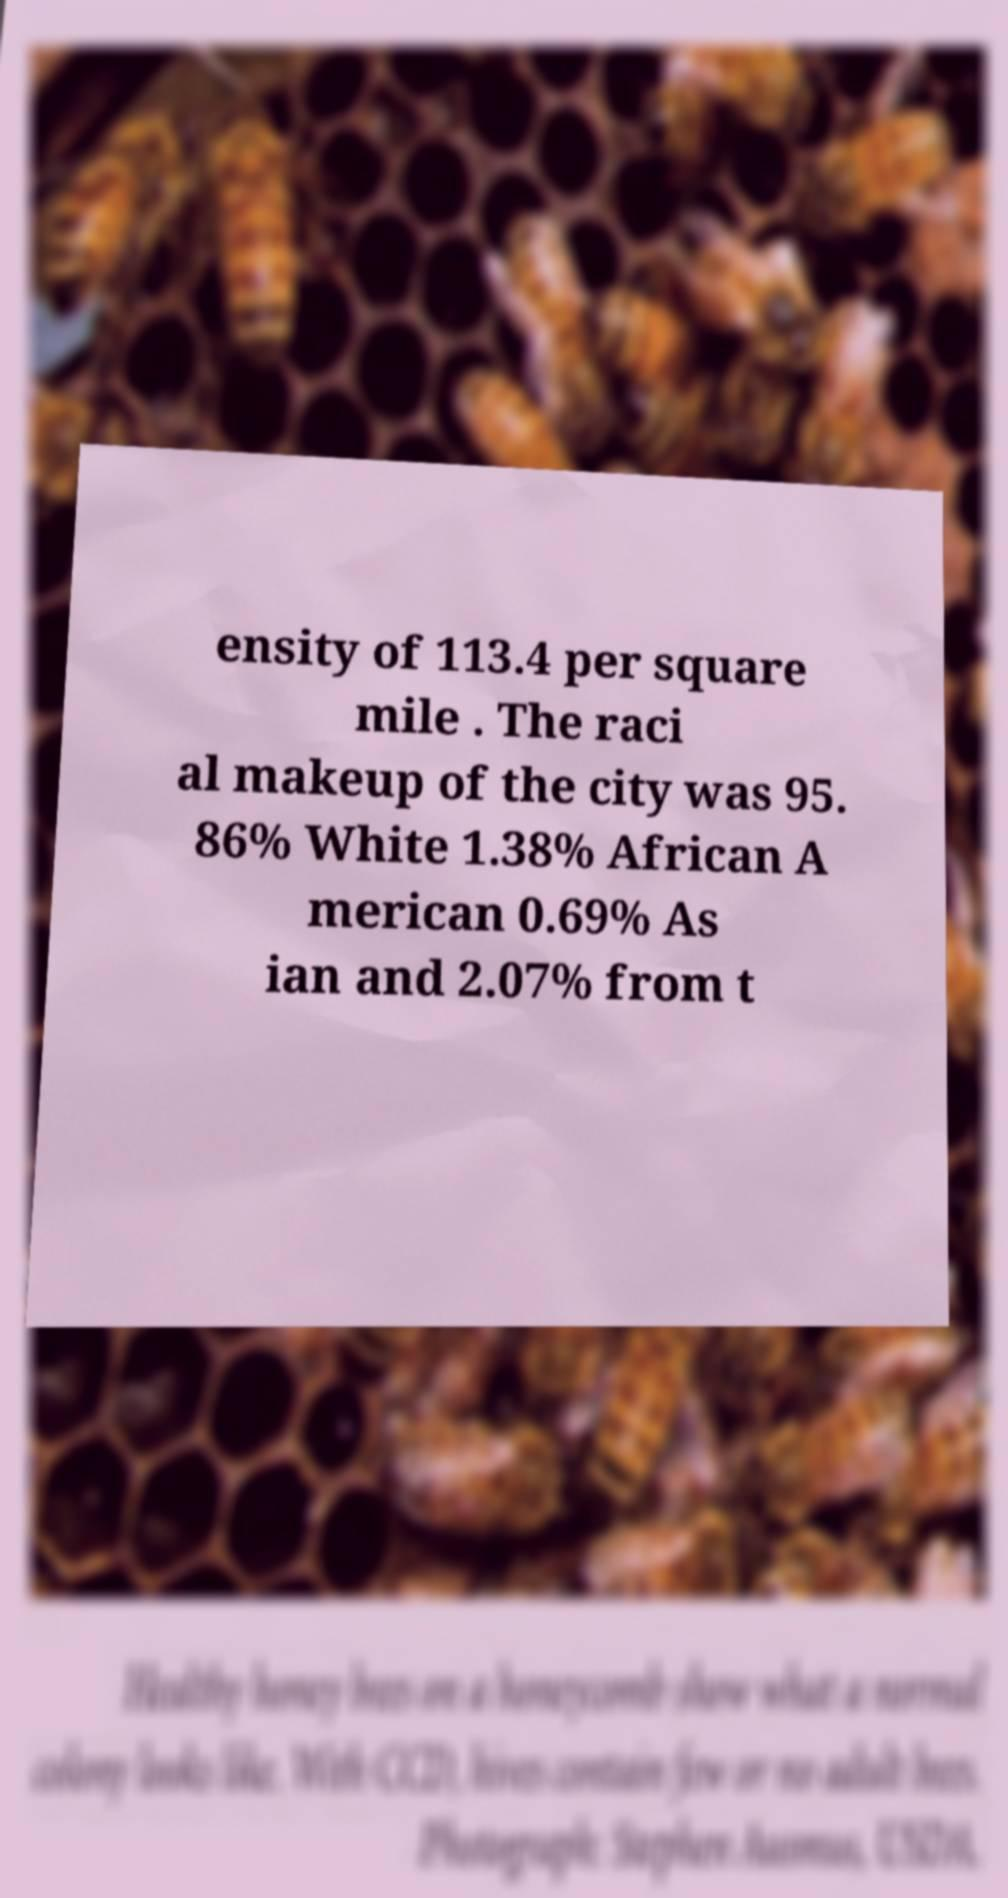There's text embedded in this image that I need extracted. Can you transcribe it verbatim? ensity of 113.4 per square mile . The raci al makeup of the city was 95. 86% White 1.38% African A merican 0.69% As ian and 2.07% from t 